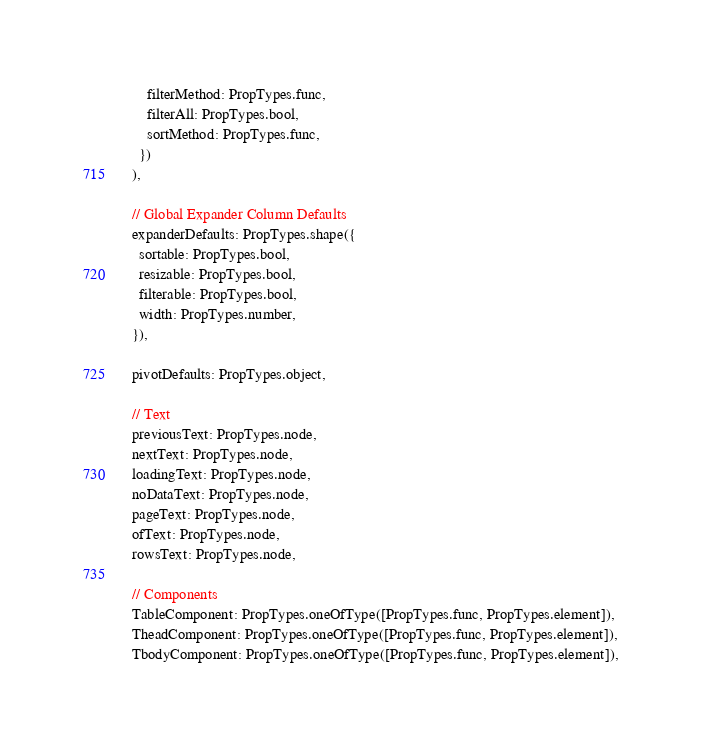Convert code to text. <code><loc_0><loc_0><loc_500><loc_500><_JavaScript_>      filterMethod: PropTypes.func,
      filterAll: PropTypes.bool,
      sortMethod: PropTypes.func,
    })
  ),

  // Global Expander Column Defaults
  expanderDefaults: PropTypes.shape({
    sortable: PropTypes.bool,
    resizable: PropTypes.bool,
    filterable: PropTypes.bool,
    width: PropTypes.number,
  }),

  pivotDefaults: PropTypes.object,

  // Text
  previousText: PropTypes.node,
  nextText: PropTypes.node,
  loadingText: PropTypes.node,
  noDataText: PropTypes.node,
  pageText: PropTypes.node,
  ofText: PropTypes.node,
  rowsText: PropTypes.node,

  // Components
  TableComponent: PropTypes.oneOfType([PropTypes.func, PropTypes.element]),
  TheadComponent: PropTypes.oneOfType([PropTypes.func, PropTypes.element]),
  TbodyComponent: PropTypes.oneOfType([PropTypes.func, PropTypes.element]),</code> 